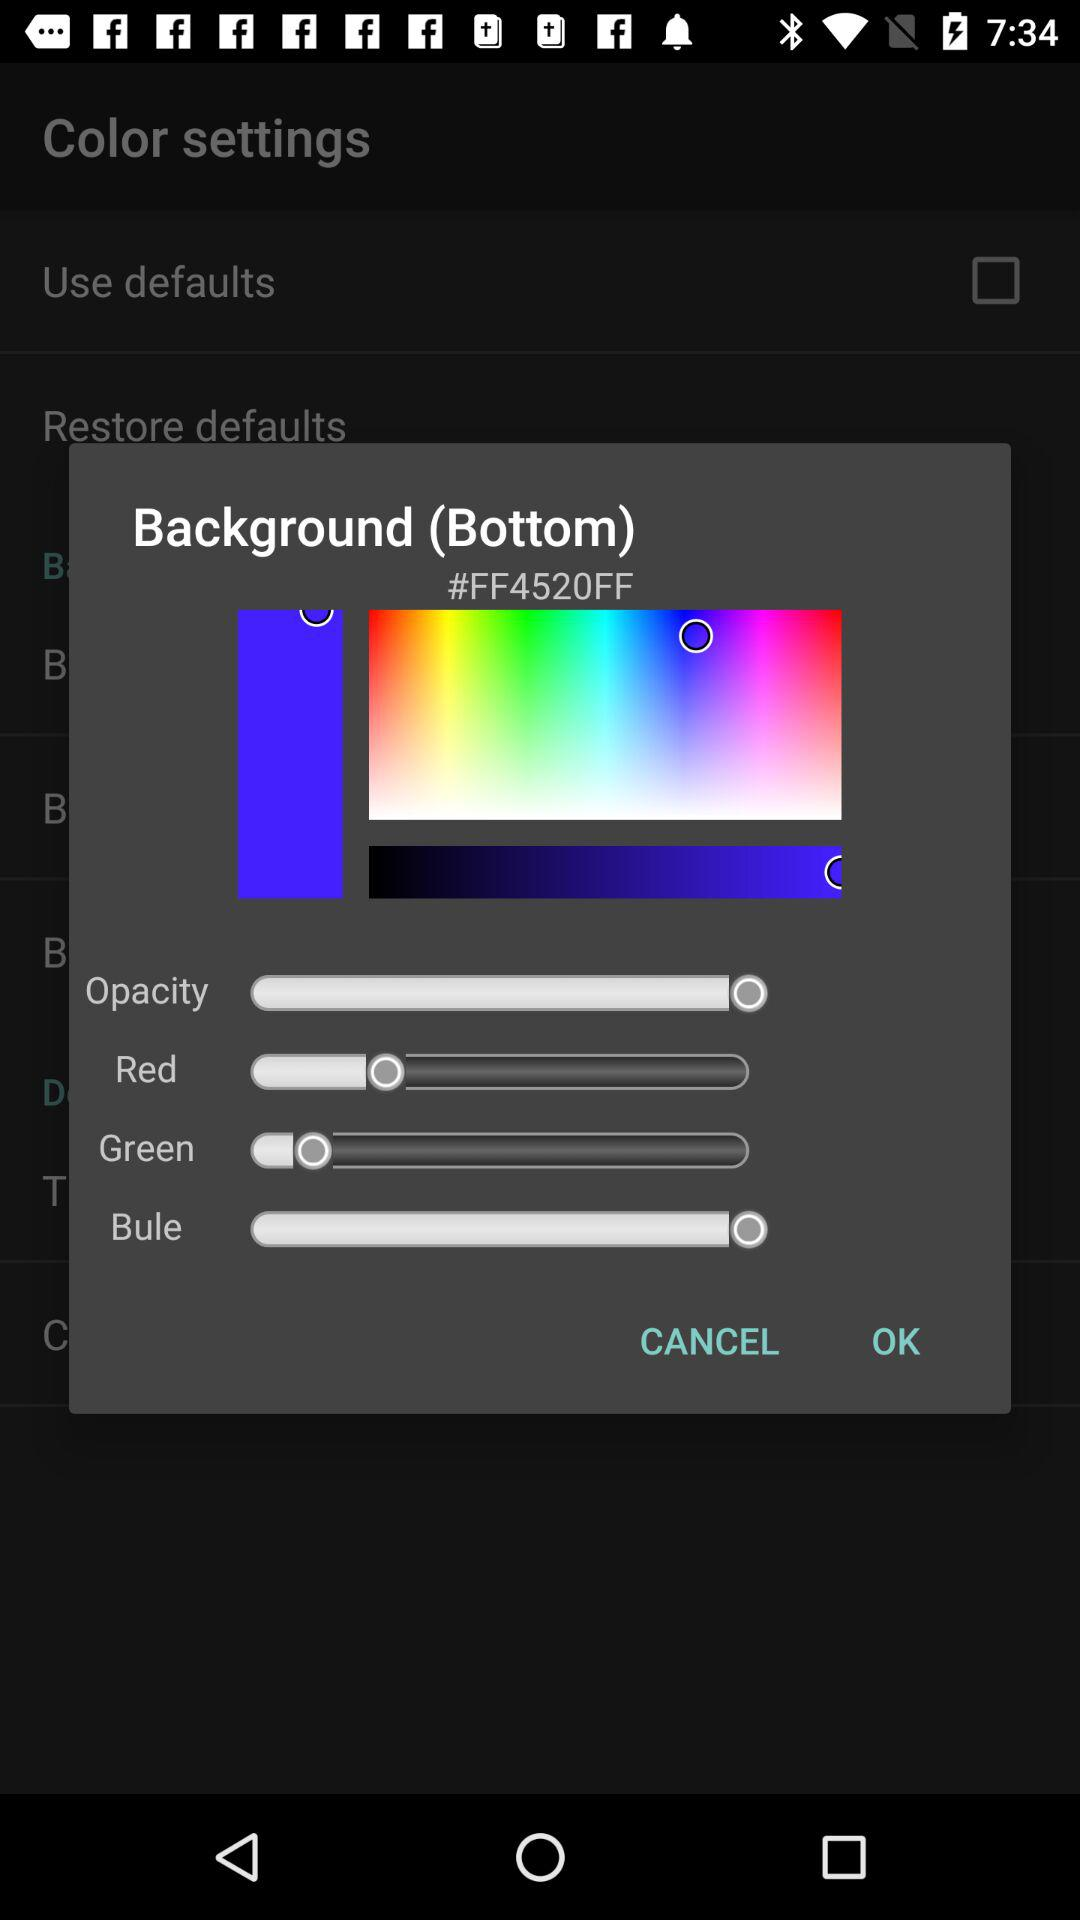What is the selected color code? The selected color code is "#FF4520FF". 